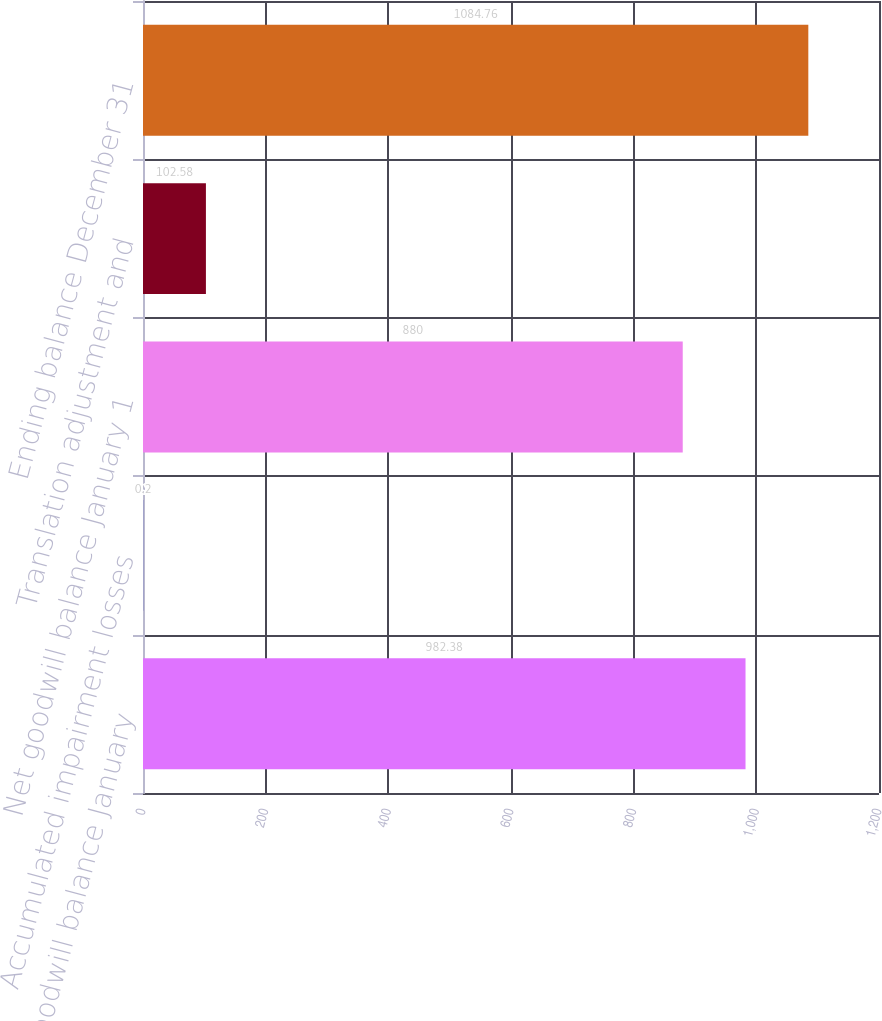Convert chart. <chart><loc_0><loc_0><loc_500><loc_500><bar_chart><fcel>Gross goodwill balance January<fcel>Accumulated impairment losses<fcel>Net goodwill balance January 1<fcel>Translation adjustment and<fcel>Ending balance December 31<nl><fcel>982.38<fcel>0.2<fcel>880<fcel>102.58<fcel>1084.76<nl></chart> 